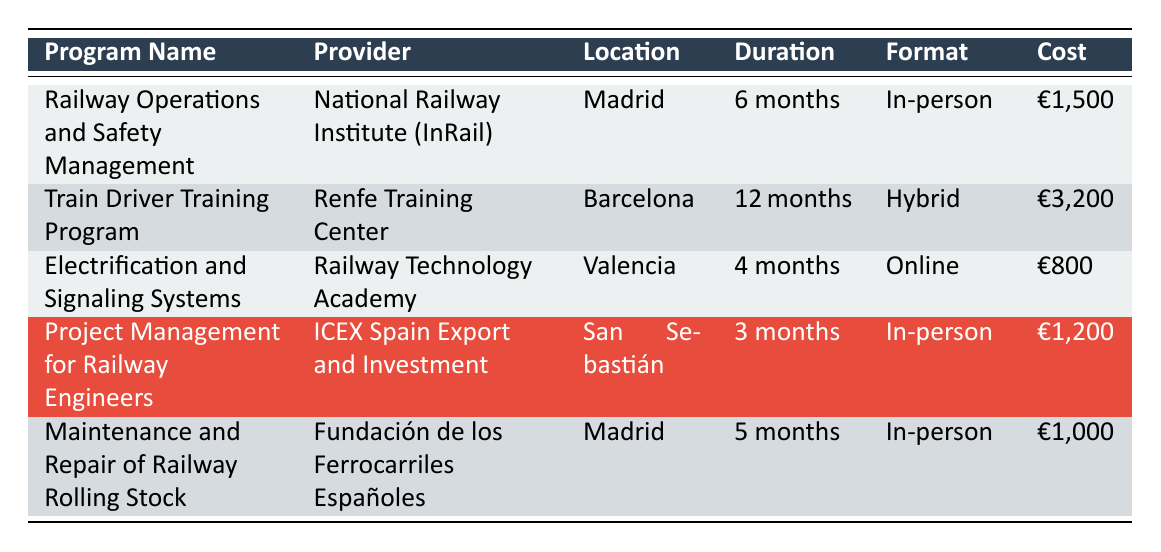What is the duration of the Train Driver Training Program? The duration is explicitly stated in the table for the Train Driver Training Program, showing "12 months".
Answer: 12 months What is the total cost of the Railway Operations and Safety Management and Maintenance and Repair of Railway Rolling Stock programs? The costs for both programs are €1,500 and €1,000 respectively. Adding these together gives €1,500 + €1,000 = €2,500.
Answer: €2,500 Is the Project Management for Railway Engineers program offered online? The format for this program is stated as "In-person", which means it is not offered online.
Answer: No Which provider offers a training program in San Sebastián? Looking at the table, the "Project Management for Railway Engineers" program is the only one listed with San Sebastián as its location, and it is provided by ICEX Spain Export and Investment.
Answer: ICEX Spain Export and Investment What is the average cost of all the training programs listed? The costs of the programs are €1,500, €3,200, €800, €1,200, and €1,000. First, sum them up: €1,500 + €3,200 + €800 + €1,200 + €1,000 = €8,700. There are 5 programs, so the average cost is €8,700 / 5 = €1,740.
Answer: €1,740 How many programs are offered in-person? By reviewing the table, there are 3 programs listed with an "In-person" format: Railway Operations and Safety Management, Project Management for Railway Engineers, and Maintenance and Repair of Railway Rolling Stock.
Answer: 3 Which program has the lowest cost and what is that cost? The costs listed are €1,500, €3,200, €800, €1,200, and €1,000. The lowest cost among these is €800 for the Electrification and Signaling Systems program.
Answer: €800 What is the location of the Electrification and Signaling Systems program? The table clearly indicates that the location for the Electrification and Signaling Systems program is Valencia, Spain.
Answer: Valencia How does the duration of the Train Driver Training Program compare to the Maintenance and Repair of Railway Rolling Stock program? The Train Driver Training Program is 12 months long while the Maintenance and Repair of Railway Rolling Stock program is 5 months long. When comparing, 12 months is longer than 5 months.
Answer: 12 months is longer than 5 months 